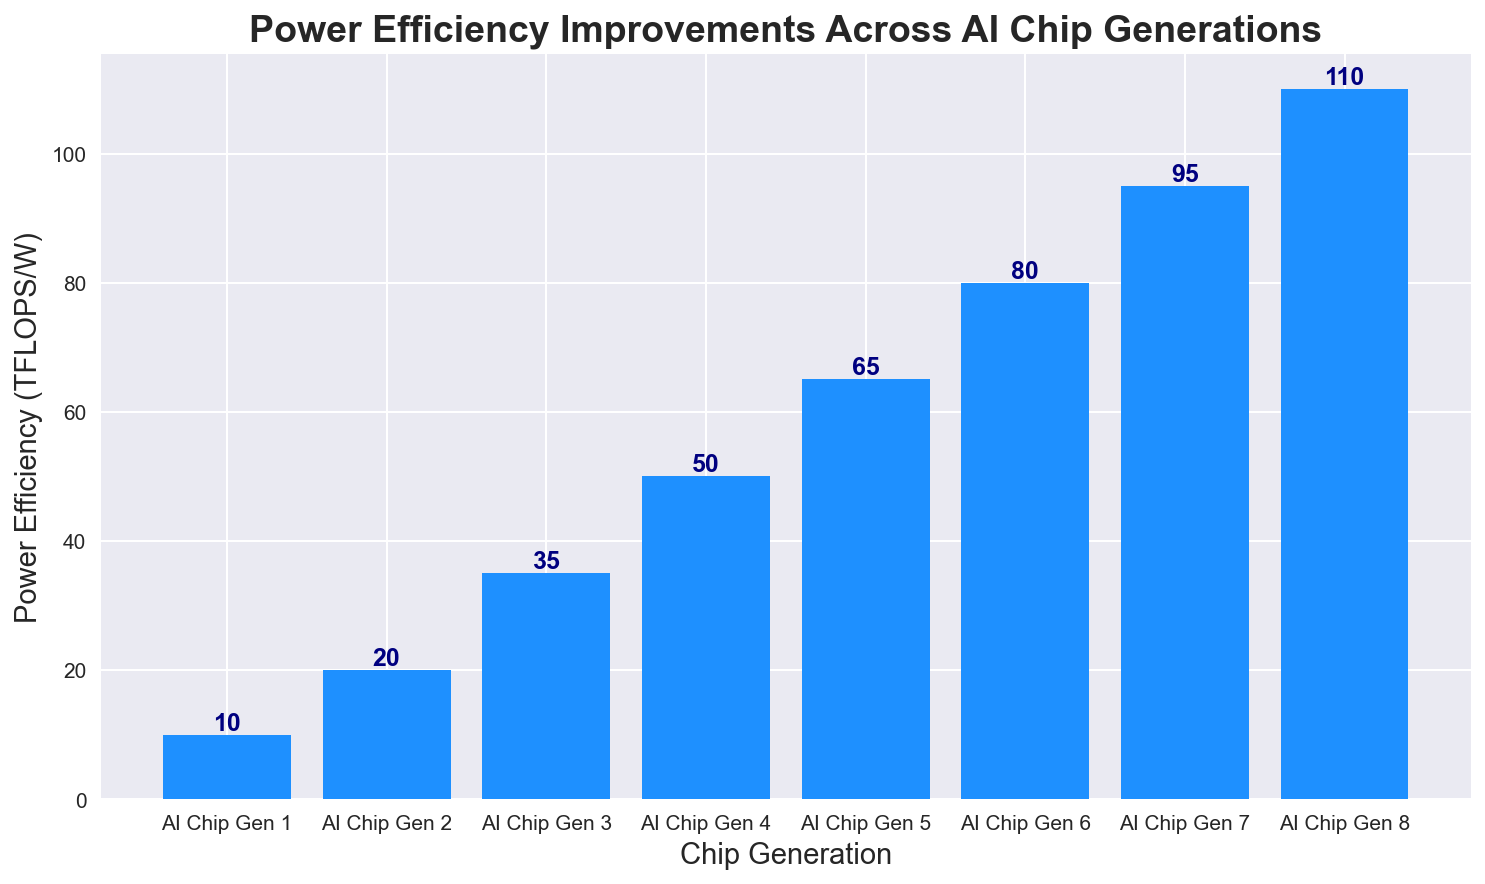Which AI chip generation has the highest power efficiency? The highest bar indicates the AI chip generation with the highest power efficiency. In this bar chart, the AI Chip Gen 8 has the bar reaching the highest value.
Answer: AI Chip Gen 8 What is the total power efficiency improvement from AI Chip Gen 1 to AI Chip Gen 8? To find the total improvement, subtract the power efficiency of AI Chip Gen 1 from that of AI Chip Gen 8. Thus, 110 - 10 = 100 TFLOPS/W.
Answer: 100 TFLOPS/W Which generation shows the most significant power efficiency improvement compared to the previous one? Compare the heights of the bars between each consecutive chip generation. The difference from AI Chip Gen 2 (20 TFLOPS/W) to AI Chip Gen 3 (35 TFLOPS/W) is 15 TFLOPS/W, which is the largest jump compared to other consecutive generations.
Answer: From AI Chip Gen 2 to AI Chip Gen 3 How does the power efficiency of AI Chip Gen 4 compare to AI Chip Gen 7? The power efficiency of AI Chip Gen 4 is 50 TFLOPS/W, and for AI Chip Gen 7, it is 95 TFLOPS/W. Since 95 > 50, AI Chip Gen 7 has higher power efficiency than AI Chip Gen 4.
Answer: AI Chip Gen 7 has higher power efficiency On average, how much does power efficiency improve per generation? Calculate the average by finding the total improvement (from 10 to 110 TFLOPS/W across 8 generations) and then dividing by the number of improvements (7, as it's between each of the 8 points). The total improvement is 100 TFLOPS/W, and 100 / 7 ≈ 14.3 TFLOPS/W per generation.
Answer: Approximately 14.3 TFLOPS/W per generation What is the combined power efficiency of AI Chip Gen 2, Gen 4, and Gen 6? Add the power efficiencies of AI Chip Gen 2 (20 TFLOPS/W), Gen 4 (50 TFLOPS/W), and Gen 6 (80 TFLOPS/W). The combined value is 20 + 50 + 80 = 150 TFLOPS/W.
Answer: 150 TFLOPS/W Which two consecutive AI chip generations show the smallest increase in power efficiency? Determine the difference between power efficiencies for each pair of consecutive generations. The smallest difference is between Gen 6 (80 TFLOPS/W) and Gen 7 (95 TFLOPS/W), which is 95 - 80 = 15 TFLOPS/W.
Answer: Between AI Chip Gen 6 and Gen 7 What is the median power efficiency value of the AI chip generations? The median value is the middle number in a sorted, ascending or descending list of numbers. For our data (10, 20, 35, 50, 65, 80, 95, 110), the median is the average of 50 and 65 (the 4th and 5th values). So, (50 + 65) / 2 = 57.5 TFLOPS/W.
Answer: 57.5 TFLOPS/W 